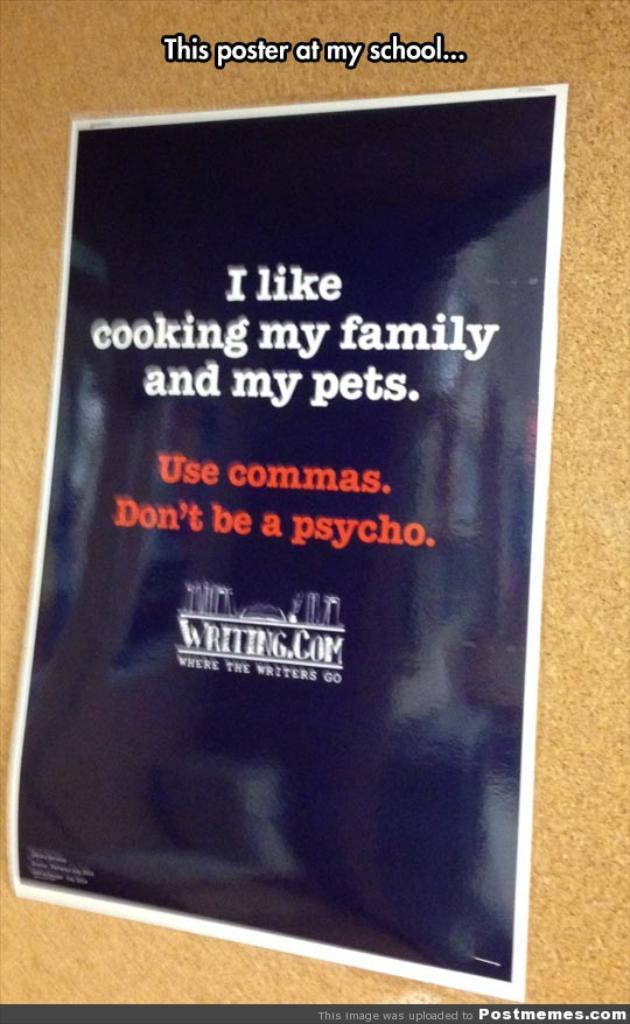<image>
Write a terse but informative summary of the picture. a poster that tells people to use commas 